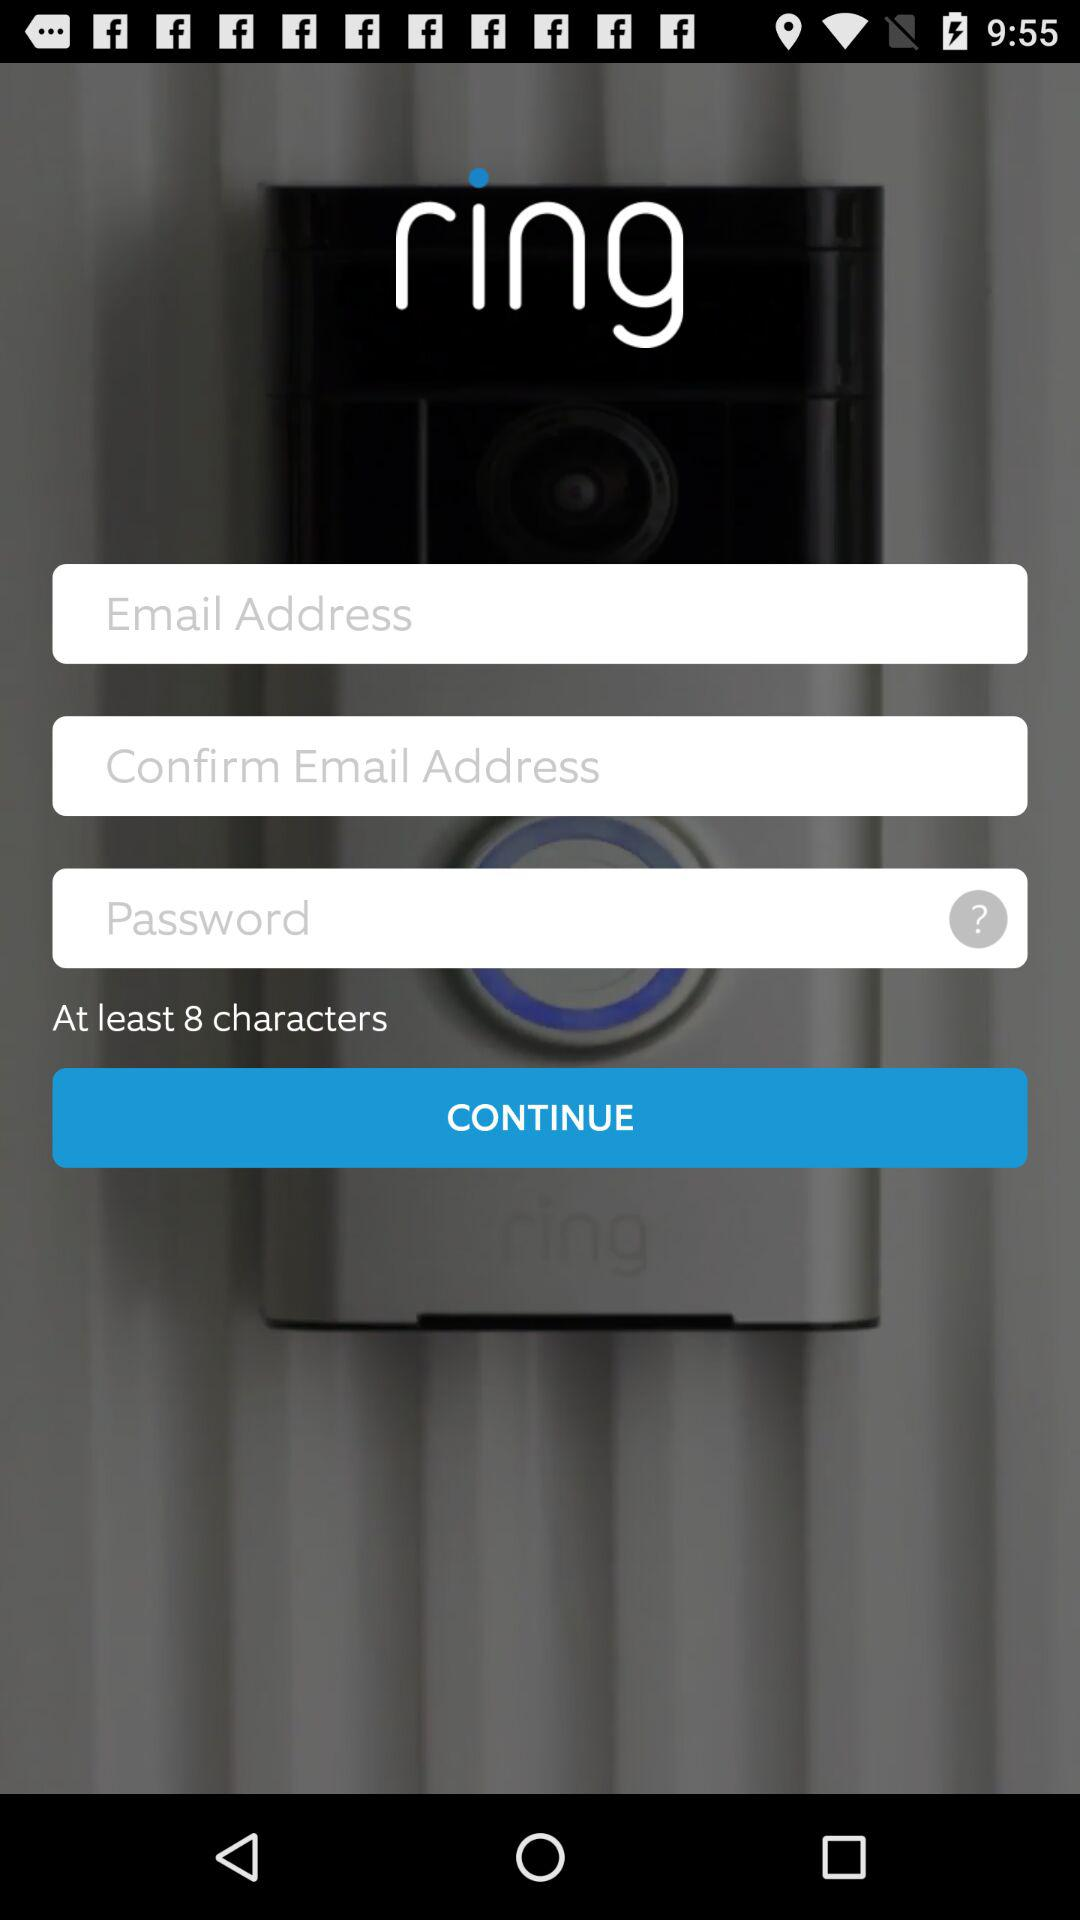What is the minimum number of characters necessary for the password? The minimum number of characters necessary for the password is 8. 